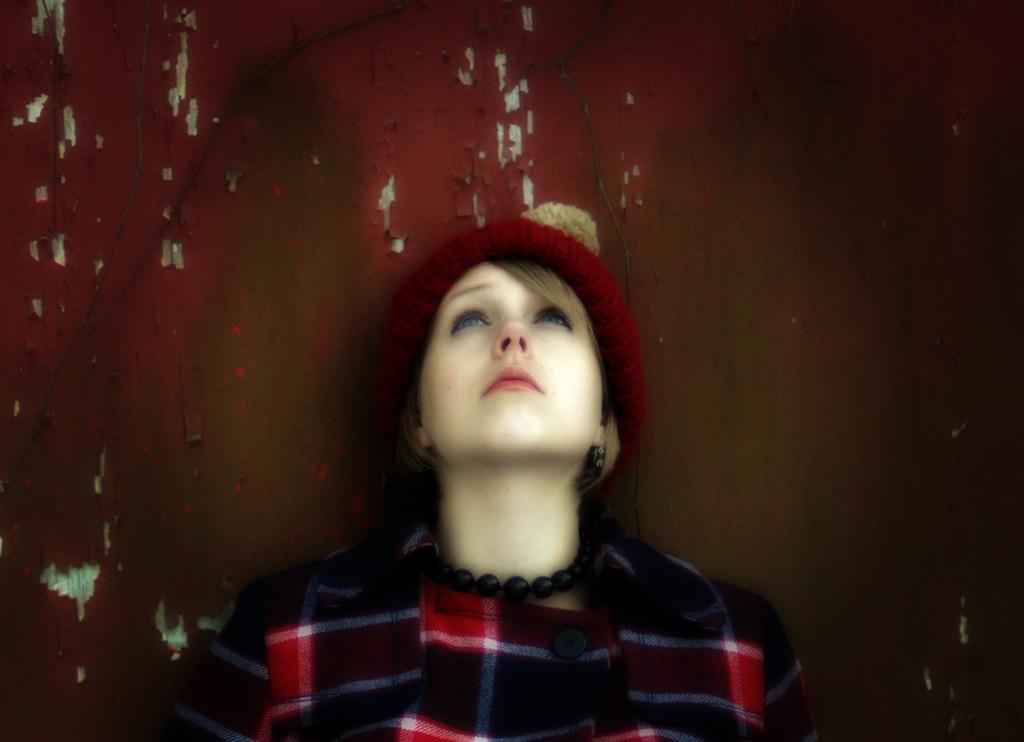Could you give a brief overview of what you see in this image? In this image we can see a woman wearing a red cap and in the background, we can see the wall. 